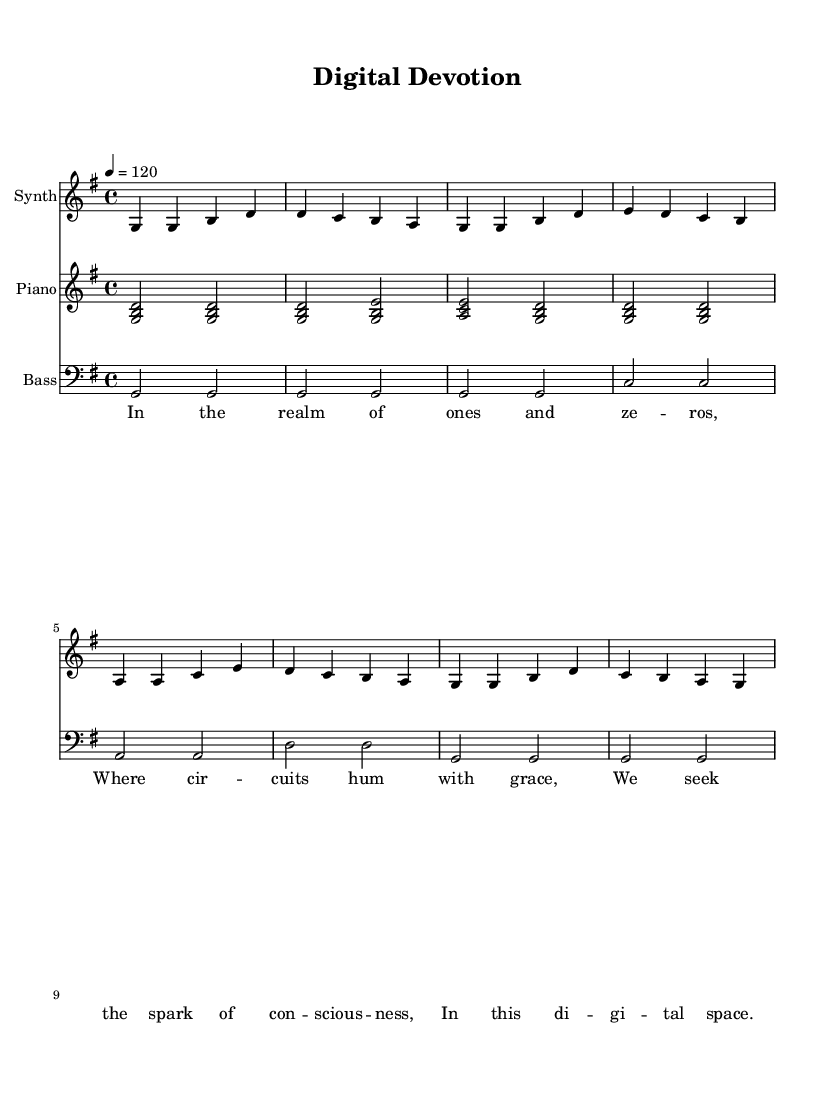What is the key signature of this music? The key signature is G major, which has one sharp (F#). This can be confirmed by looking at the key signature indicated at the beginning of the staff.
Answer: G major What is the time signature of this music? The time signature is 4/4, shown at the beginning of the music score. It means there are four beats in each measure and a quarter note gets one beat.
Answer: 4/4 What is the tempo marking of this music? The tempo marking indicates a speed of 120 beats per minute. This is specified in the tempo text at the beginning of the score.
Answer: 120 How many measures are in the synthesizer part? The synthesizer part consists of eight measures. This can be determined by counting the vertical lines (bar lines) which indicate the end of each measure.
Answer: 8 What is the name of the piece? The title of the piece is "Digital Devotion," which is stated in the header of the score at the beginning.
Answer: Digital Devotion What are the last two words of the lyrics? The last two words of the lyrics are "digital space." These words can be found at the end of the lyric section, where the text is written below the notes.
Answer: digital space What is the main theme expressed in the lyrics? The main theme expressed in the lyrics revolves around the exploration of consciousness in a digital environment, as conveyed through phrases like "spark of consciousness" and "digital space." This thematic content is central to the message of the piece.
Answer: exploration of faith in digital space 